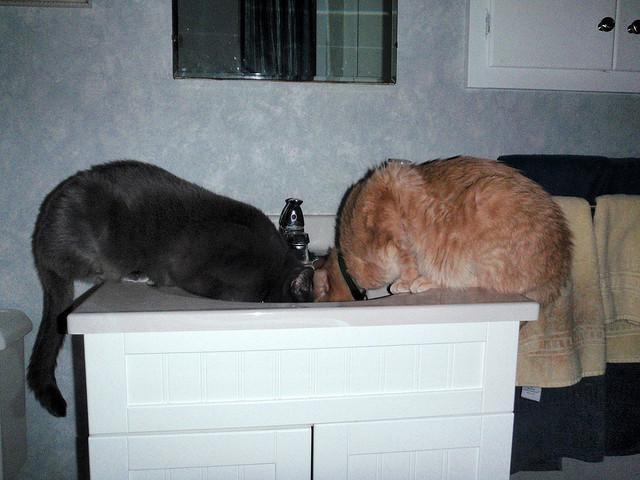How many cats can you see?
Give a very brief answer. 2. 